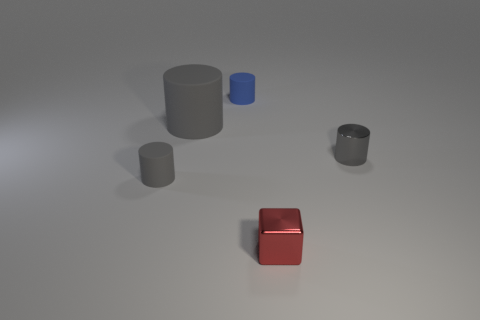What number of large objects are either gray shiny objects or rubber things?
Give a very brief answer. 1. How many gray metallic cylinders are to the left of the cube?
Your answer should be compact. 0. Are there any small cylinders that have the same color as the big cylinder?
Give a very brief answer. Yes. There is a red metallic thing that is the same size as the metallic cylinder; what shape is it?
Offer a terse response. Cube. How many yellow things are either matte cylinders or metallic cylinders?
Offer a terse response. 0. How many blue matte cylinders are the same size as the metallic block?
Give a very brief answer. 1. There is a large rubber object that is the same color as the metallic cylinder; what shape is it?
Provide a succinct answer. Cylinder. How many things are small red shiny things or shiny things in front of the tiny gray rubber cylinder?
Your answer should be compact. 1. There is a shiny object behind the small gray rubber object; is its size the same as the matte thing on the right side of the large cylinder?
Provide a short and direct response. Yes. How many big brown matte objects are the same shape as the large gray matte object?
Your answer should be very brief. 0. 